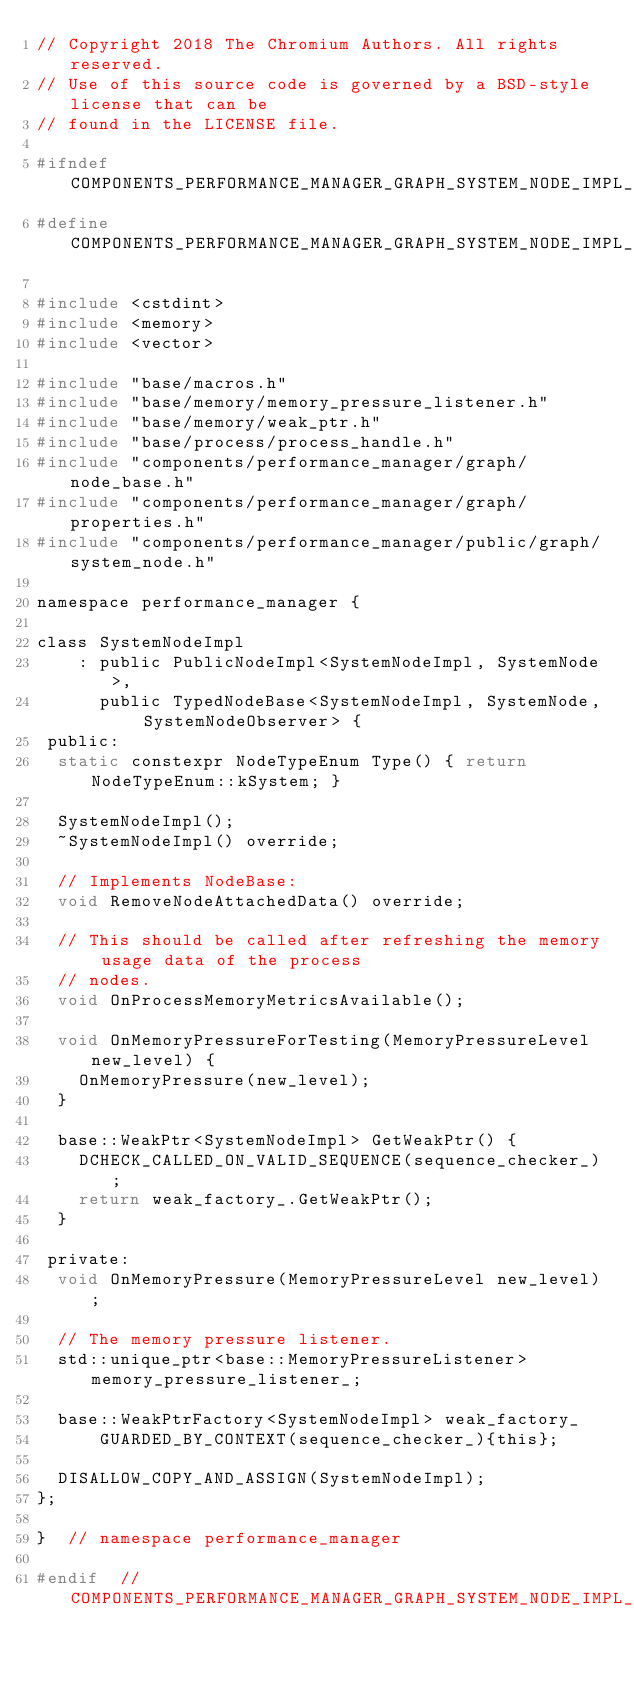Convert code to text. <code><loc_0><loc_0><loc_500><loc_500><_C_>// Copyright 2018 The Chromium Authors. All rights reserved.
// Use of this source code is governed by a BSD-style license that can be
// found in the LICENSE file.

#ifndef COMPONENTS_PERFORMANCE_MANAGER_GRAPH_SYSTEM_NODE_IMPL_H_
#define COMPONENTS_PERFORMANCE_MANAGER_GRAPH_SYSTEM_NODE_IMPL_H_

#include <cstdint>
#include <memory>
#include <vector>

#include "base/macros.h"
#include "base/memory/memory_pressure_listener.h"
#include "base/memory/weak_ptr.h"
#include "base/process/process_handle.h"
#include "components/performance_manager/graph/node_base.h"
#include "components/performance_manager/graph/properties.h"
#include "components/performance_manager/public/graph/system_node.h"

namespace performance_manager {

class SystemNodeImpl
    : public PublicNodeImpl<SystemNodeImpl, SystemNode>,
      public TypedNodeBase<SystemNodeImpl, SystemNode, SystemNodeObserver> {
 public:
  static constexpr NodeTypeEnum Type() { return NodeTypeEnum::kSystem; }

  SystemNodeImpl();
  ~SystemNodeImpl() override;

  // Implements NodeBase:
  void RemoveNodeAttachedData() override;

  // This should be called after refreshing the memory usage data of the process
  // nodes.
  void OnProcessMemoryMetricsAvailable();

  void OnMemoryPressureForTesting(MemoryPressureLevel new_level) {
    OnMemoryPressure(new_level);
  }

  base::WeakPtr<SystemNodeImpl> GetWeakPtr() {
    DCHECK_CALLED_ON_VALID_SEQUENCE(sequence_checker_);
    return weak_factory_.GetWeakPtr();
  }

 private:
  void OnMemoryPressure(MemoryPressureLevel new_level);

  // The memory pressure listener.
  std::unique_ptr<base::MemoryPressureListener> memory_pressure_listener_;

  base::WeakPtrFactory<SystemNodeImpl> weak_factory_
      GUARDED_BY_CONTEXT(sequence_checker_){this};

  DISALLOW_COPY_AND_ASSIGN(SystemNodeImpl);
};

}  // namespace performance_manager

#endif  // COMPONENTS_PERFORMANCE_MANAGER_GRAPH_SYSTEM_NODE_IMPL_H_
</code> 